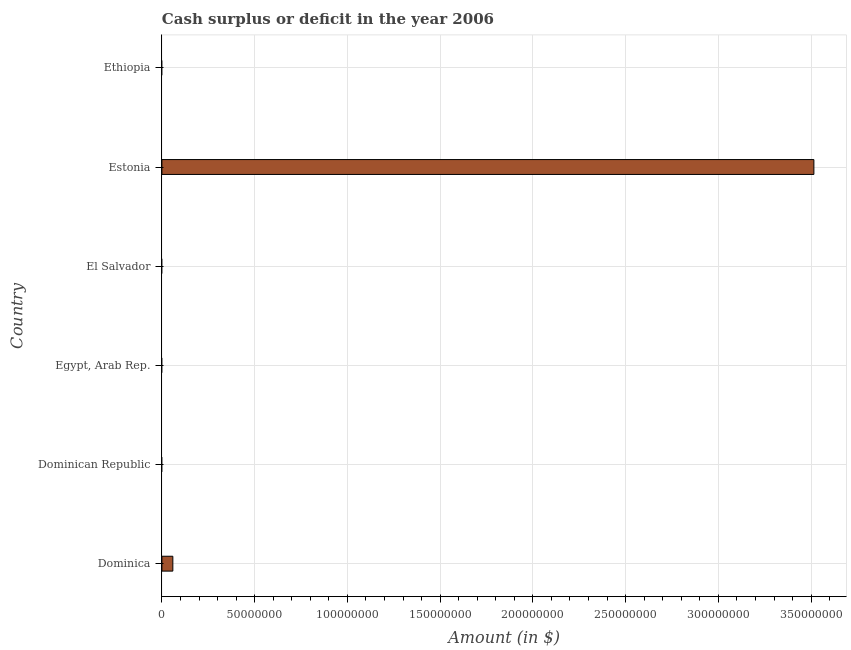What is the title of the graph?
Your answer should be very brief. Cash surplus or deficit in the year 2006. What is the label or title of the X-axis?
Give a very brief answer. Amount (in $). What is the label or title of the Y-axis?
Your response must be concise. Country. Across all countries, what is the maximum cash surplus or deficit?
Ensure brevity in your answer.  3.52e+08. Across all countries, what is the minimum cash surplus or deficit?
Your answer should be compact. 0. In which country was the cash surplus or deficit maximum?
Your answer should be compact. Estonia. What is the sum of the cash surplus or deficit?
Your answer should be compact. 3.57e+08. What is the difference between the cash surplus or deficit in Dominica and Estonia?
Provide a short and direct response. -3.46e+08. What is the average cash surplus or deficit per country?
Make the answer very short. 5.96e+07. What is the median cash surplus or deficit?
Give a very brief answer. 0. What is the ratio of the cash surplus or deficit in Dominica to that in Estonia?
Provide a succinct answer. 0.02. What is the difference between the highest and the lowest cash surplus or deficit?
Ensure brevity in your answer.  3.52e+08. In how many countries, is the cash surplus or deficit greater than the average cash surplus or deficit taken over all countries?
Your answer should be very brief. 1. Are all the bars in the graph horizontal?
Offer a terse response. Yes. How many countries are there in the graph?
Your answer should be compact. 6. What is the difference between two consecutive major ticks on the X-axis?
Your response must be concise. 5.00e+07. What is the Amount (in $) of Dominica?
Give a very brief answer. 5.90e+06. What is the Amount (in $) in Egypt, Arab Rep.?
Offer a terse response. 0. What is the Amount (in $) in Estonia?
Your answer should be very brief. 3.52e+08. What is the difference between the Amount (in $) in Dominica and Estonia?
Make the answer very short. -3.46e+08. What is the ratio of the Amount (in $) in Dominica to that in Estonia?
Offer a very short reply. 0.02. 